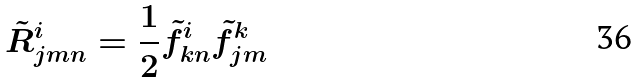<formula> <loc_0><loc_0><loc_500><loc_500>\tilde { R } _ { j m n } ^ { i } = \frac { 1 } { 2 } \tilde { f } _ { k n } ^ { i } \tilde { f } _ { j m } ^ { k }</formula> 